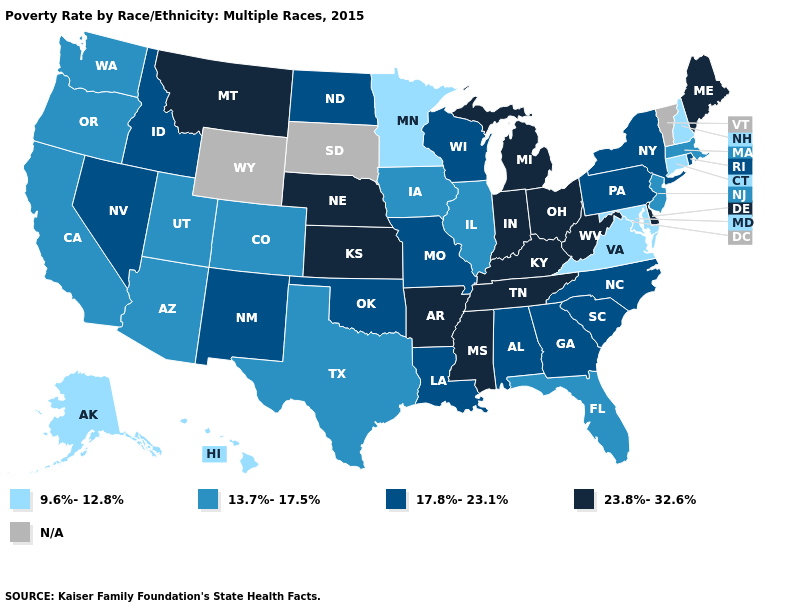What is the highest value in the USA?
Answer briefly. 23.8%-32.6%. Name the states that have a value in the range 9.6%-12.8%?
Short answer required. Alaska, Connecticut, Hawaii, Maryland, Minnesota, New Hampshire, Virginia. Name the states that have a value in the range 23.8%-32.6%?
Short answer required. Arkansas, Delaware, Indiana, Kansas, Kentucky, Maine, Michigan, Mississippi, Montana, Nebraska, Ohio, Tennessee, West Virginia. Name the states that have a value in the range 17.8%-23.1%?
Concise answer only. Alabama, Georgia, Idaho, Louisiana, Missouri, Nevada, New Mexico, New York, North Carolina, North Dakota, Oklahoma, Pennsylvania, Rhode Island, South Carolina, Wisconsin. What is the value of New Mexico?
Short answer required. 17.8%-23.1%. Among the states that border Maryland , does Delaware have the lowest value?
Give a very brief answer. No. What is the lowest value in the USA?
Keep it brief. 9.6%-12.8%. Which states have the highest value in the USA?
Give a very brief answer. Arkansas, Delaware, Indiana, Kansas, Kentucky, Maine, Michigan, Mississippi, Montana, Nebraska, Ohio, Tennessee, West Virginia. What is the highest value in the USA?
Short answer required. 23.8%-32.6%. Which states have the lowest value in the USA?
Be succinct. Alaska, Connecticut, Hawaii, Maryland, Minnesota, New Hampshire, Virginia. Name the states that have a value in the range N/A?
Be succinct. South Dakota, Vermont, Wyoming. Name the states that have a value in the range 23.8%-32.6%?
Quick response, please. Arkansas, Delaware, Indiana, Kansas, Kentucky, Maine, Michigan, Mississippi, Montana, Nebraska, Ohio, Tennessee, West Virginia. What is the value of Texas?
Be succinct. 13.7%-17.5%. 